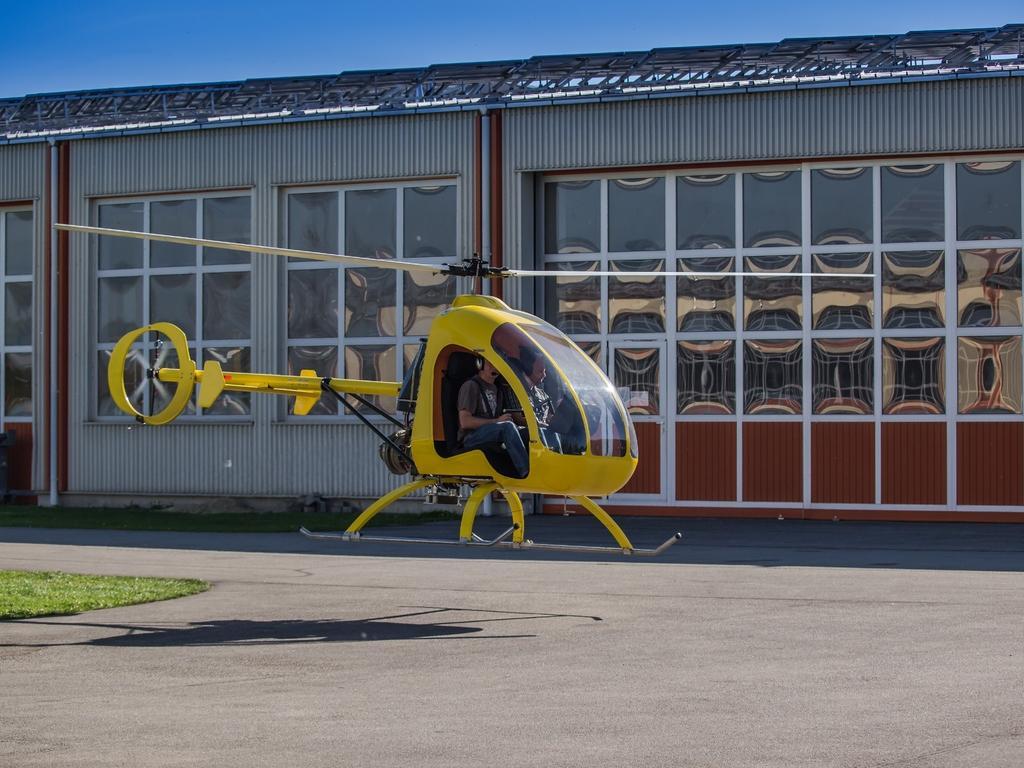Can you describe this image briefly? In the foreground, I can see grass and a helicopter in the air. In the background, I can see a building, windows and the sky. This picture might be taken in a day. 